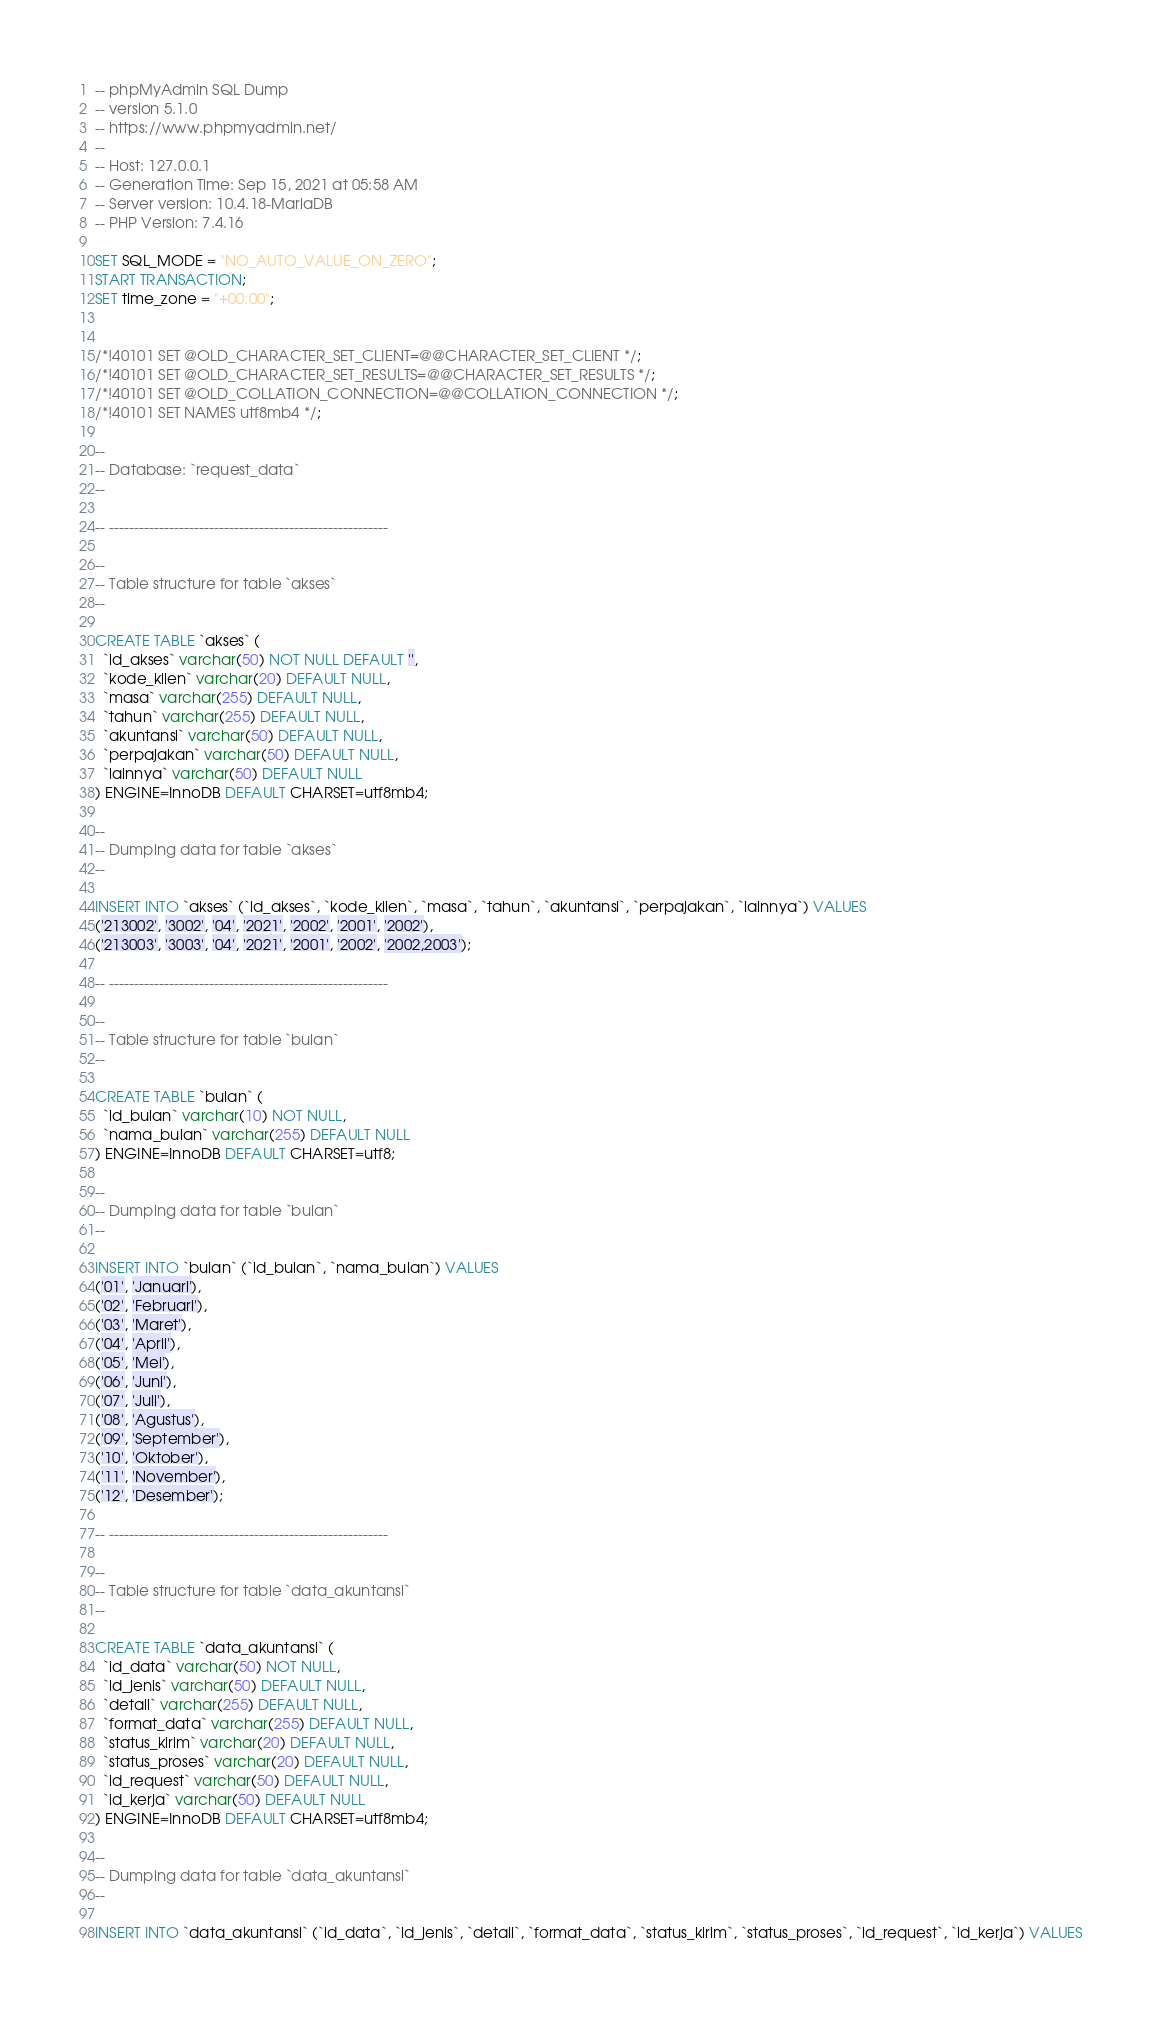Convert code to text. <code><loc_0><loc_0><loc_500><loc_500><_SQL_>-- phpMyAdmin SQL Dump
-- version 5.1.0
-- https://www.phpmyadmin.net/
--
-- Host: 127.0.0.1
-- Generation Time: Sep 15, 2021 at 05:58 AM
-- Server version: 10.4.18-MariaDB
-- PHP Version: 7.4.16

SET SQL_MODE = "NO_AUTO_VALUE_ON_ZERO";
START TRANSACTION;
SET time_zone = "+00:00";


/*!40101 SET @OLD_CHARACTER_SET_CLIENT=@@CHARACTER_SET_CLIENT */;
/*!40101 SET @OLD_CHARACTER_SET_RESULTS=@@CHARACTER_SET_RESULTS */;
/*!40101 SET @OLD_COLLATION_CONNECTION=@@COLLATION_CONNECTION */;
/*!40101 SET NAMES utf8mb4 */;

--
-- Database: `request_data`
--

-- --------------------------------------------------------

--
-- Table structure for table `akses`
--

CREATE TABLE `akses` (
  `id_akses` varchar(50) NOT NULL DEFAULT '',
  `kode_klien` varchar(20) DEFAULT NULL,
  `masa` varchar(255) DEFAULT NULL,
  `tahun` varchar(255) DEFAULT NULL,
  `akuntansi` varchar(50) DEFAULT NULL,
  `perpajakan` varchar(50) DEFAULT NULL,
  `lainnya` varchar(50) DEFAULT NULL
) ENGINE=InnoDB DEFAULT CHARSET=utf8mb4;

--
-- Dumping data for table `akses`
--

INSERT INTO `akses` (`id_akses`, `kode_klien`, `masa`, `tahun`, `akuntansi`, `perpajakan`, `lainnya`) VALUES
('213002', '3002', '04', '2021', '2002', '2001', '2002'),
('213003', '3003', '04', '2021', '2001', '2002', '2002,2003');

-- --------------------------------------------------------

--
-- Table structure for table `bulan`
--

CREATE TABLE `bulan` (
  `id_bulan` varchar(10) NOT NULL,
  `nama_bulan` varchar(255) DEFAULT NULL
) ENGINE=InnoDB DEFAULT CHARSET=utf8;

--
-- Dumping data for table `bulan`
--

INSERT INTO `bulan` (`id_bulan`, `nama_bulan`) VALUES
('01', 'Januari'),
('02', 'Februari'),
('03', 'Maret'),
('04', 'April'),
('05', 'Mei'),
('06', 'Juni'),
('07', 'Juli'),
('08', 'Agustus'),
('09', 'September'),
('10', 'Oktober'),
('11', 'November'),
('12', 'Desember');

-- --------------------------------------------------------

--
-- Table structure for table `data_akuntansi`
--

CREATE TABLE `data_akuntansi` (
  `id_data` varchar(50) NOT NULL,
  `id_jenis` varchar(50) DEFAULT NULL,
  `detail` varchar(255) DEFAULT NULL,
  `format_data` varchar(255) DEFAULT NULL,
  `status_kirim` varchar(20) DEFAULT NULL,
  `status_proses` varchar(20) DEFAULT NULL,
  `id_request` varchar(50) DEFAULT NULL,
  `id_kerja` varchar(50) DEFAULT NULL
) ENGINE=InnoDB DEFAULT CHARSET=utf8mb4;

--
-- Dumping data for table `data_akuntansi`
--

INSERT INTO `data_akuntansi` (`id_data`, `id_jenis`, `detail`, `format_data`, `status_kirim`, `status_proses`, `id_request`, `id_kerja`) VALUES</code> 